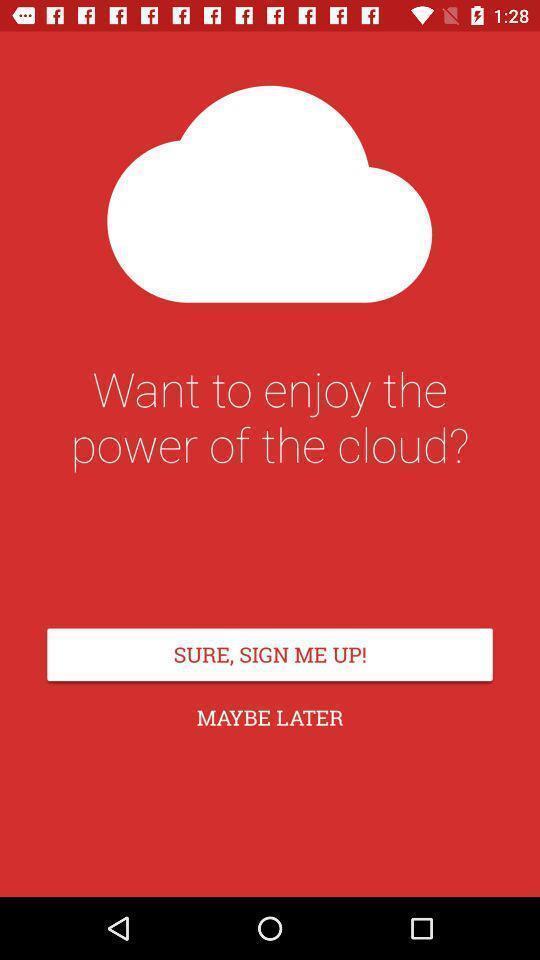Summarize the main components in this picture. Sign up page. 